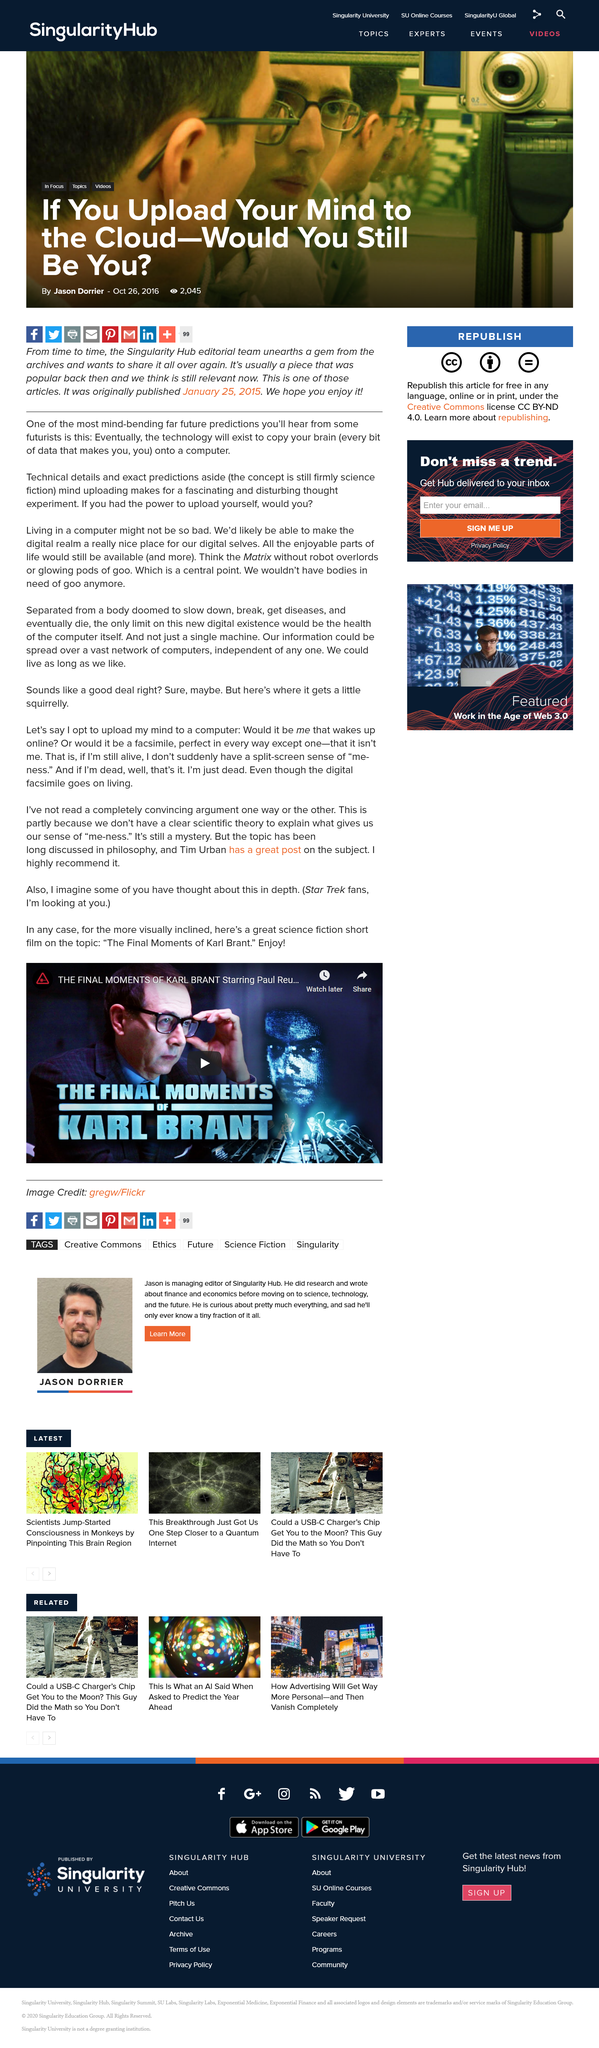Draw attention to some important aspects in this diagram. The image credit belongs to Gregw/Flickr. The video is about the final moments of Karl Brant. The film 'The final moments of Karl Brant' is classified as science fiction, as it belongs to the genre of science fiction. 